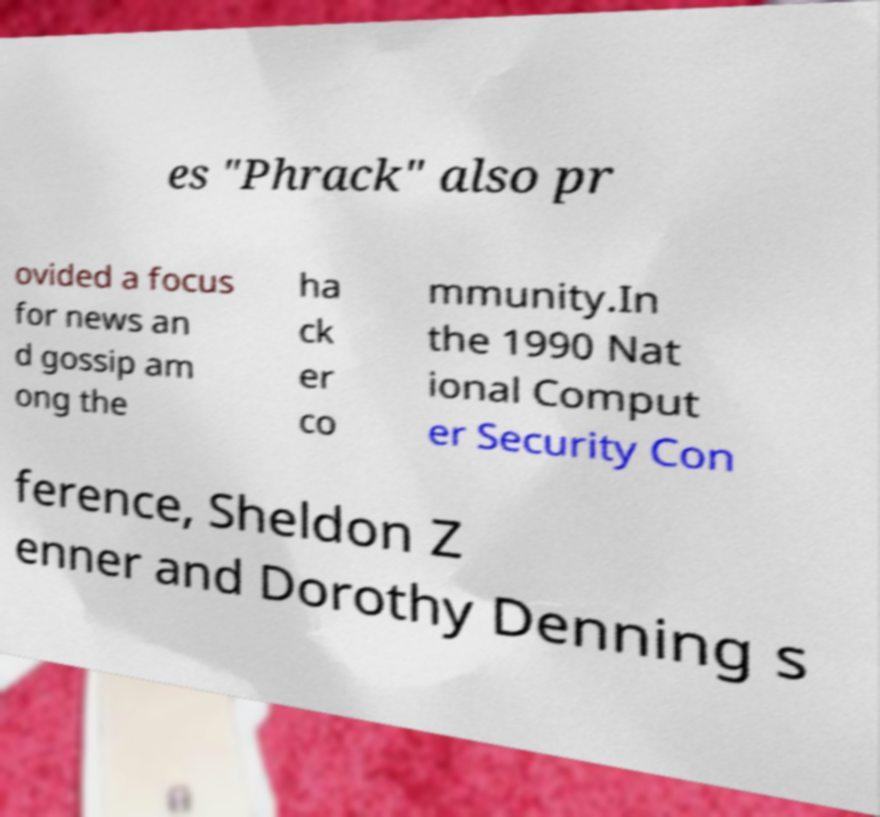Could you assist in decoding the text presented in this image and type it out clearly? es "Phrack" also pr ovided a focus for news an d gossip am ong the ha ck er co mmunity.In the 1990 Nat ional Comput er Security Con ference, Sheldon Z enner and Dorothy Denning s 